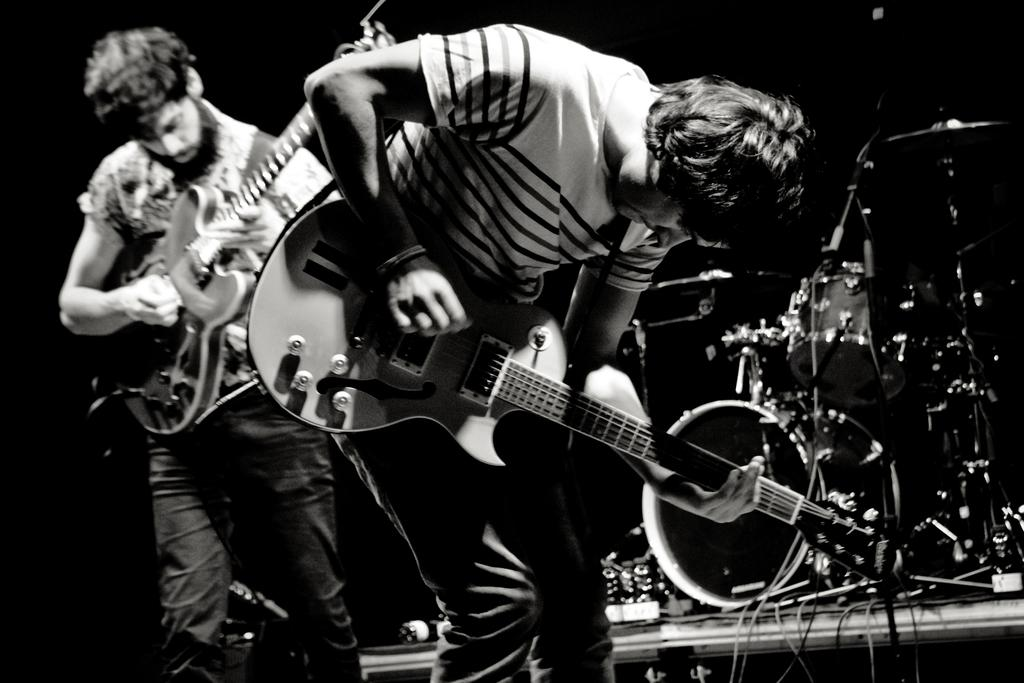How many people are in the image? There are two men in the image. What are the men doing in the image? The men are playing guitars. Where are the men located in the image? The men are standing on a stage. What else can be seen in the background of the image? There are other musical instruments in the background. How many ants can be seen crawling on the keys of the guitar in the image? There are no ants visible in the image, and no ants are crawling on the keys of the guitar. 